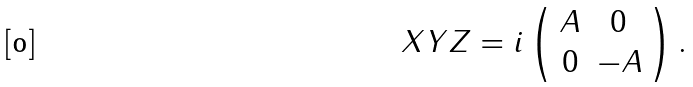<formula> <loc_0><loc_0><loc_500><loc_500>X Y Z = i \left ( \begin{array} { c c } A & 0 \\ 0 & - A \end{array} \right ) .</formula> 